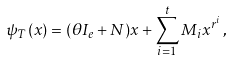Convert formula to latex. <formula><loc_0><loc_0><loc_500><loc_500>\psi _ { T } ( x ) = ( \theta I _ { e } + N ) x + \sum _ { i = 1 } ^ { t } M _ { i } x ^ { r ^ { i } } \, ,</formula> 